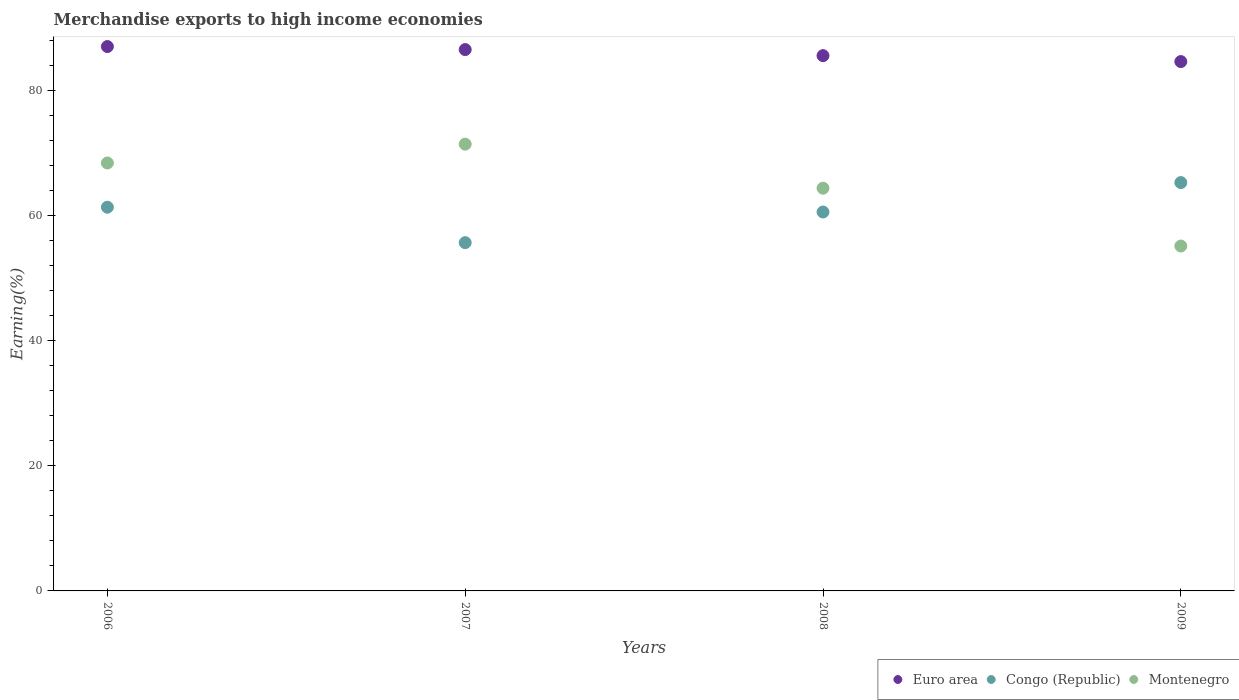How many different coloured dotlines are there?
Give a very brief answer. 3. Is the number of dotlines equal to the number of legend labels?
Give a very brief answer. Yes. What is the percentage of amount earned from merchandise exports in Montenegro in 2007?
Keep it short and to the point. 71.38. Across all years, what is the maximum percentage of amount earned from merchandise exports in Montenegro?
Offer a very short reply. 71.38. Across all years, what is the minimum percentage of amount earned from merchandise exports in Congo (Republic)?
Offer a very short reply. 55.64. In which year was the percentage of amount earned from merchandise exports in Euro area maximum?
Make the answer very short. 2006. In which year was the percentage of amount earned from merchandise exports in Euro area minimum?
Offer a terse response. 2009. What is the total percentage of amount earned from merchandise exports in Congo (Republic) in the graph?
Give a very brief answer. 242.73. What is the difference between the percentage of amount earned from merchandise exports in Montenegro in 2007 and that in 2008?
Ensure brevity in your answer.  7.04. What is the difference between the percentage of amount earned from merchandise exports in Euro area in 2007 and the percentage of amount earned from merchandise exports in Montenegro in 2009?
Give a very brief answer. 31.39. What is the average percentage of amount earned from merchandise exports in Congo (Republic) per year?
Provide a short and direct response. 60.68. In the year 2007, what is the difference between the percentage of amount earned from merchandise exports in Montenegro and percentage of amount earned from merchandise exports in Euro area?
Your answer should be very brief. -15.11. In how many years, is the percentage of amount earned from merchandise exports in Montenegro greater than 20 %?
Give a very brief answer. 4. What is the ratio of the percentage of amount earned from merchandise exports in Euro area in 2006 to that in 2009?
Provide a succinct answer. 1.03. Is the difference between the percentage of amount earned from merchandise exports in Montenegro in 2006 and 2008 greater than the difference between the percentage of amount earned from merchandise exports in Euro area in 2006 and 2008?
Your response must be concise. Yes. What is the difference between the highest and the second highest percentage of amount earned from merchandise exports in Euro area?
Ensure brevity in your answer.  0.48. What is the difference between the highest and the lowest percentage of amount earned from merchandise exports in Euro area?
Offer a terse response. 2.4. Is it the case that in every year, the sum of the percentage of amount earned from merchandise exports in Congo (Republic) and percentage of amount earned from merchandise exports in Euro area  is greater than the percentage of amount earned from merchandise exports in Montenegro?
Provide a succinct answer. Yes. Does the percentage of amount earned from merchandise exports in Euro area monotonically increase over the years?
Keep it short and to the point. No. Is the percentage of amount earned from merchandise exports in Congo (Republic) strictly less than the percentage of amount earned from merchandise exports in Euro area over the years?
Offer a very short reply. Yes. How many years are there in the graph?
Keep it short and to the point. 4. What is the difference between two consecutive major ticks on the Y-axis?
Offer a terse response. 20. Does the graph contain grids?
Provide a succinct answer. No. What is the title of the graph?
Your response must be concise. Merchandise exports to high income economies. Does "Nepal" appear as one of the legend labels in the graph?
Keep it short and to the point. No. What is the label or title of the X-axis?
Your answer should be very brief. Years. What is the label or title of the Y-axis?
Your response must be concise. Earning(%). What is the Earning(%) of Euro area in 2006?
Provide a short and direct response. 86.97. What is the Earning(%) of Congo (Republic) in 2006?
Your answer should be very brief. 61.3. What is the Earning(%) in Montenegro in 2006?
Provide a short and direct response. 68.37. What is the Earning(%) of Euro area in 2007?
Your response must be concise. 86.49. What is the Earning(%) in Congo (Republic) in 2007?
Your response must be concise. 55.64. What is the Earning(%) in Montenegro in 2007?
Offer a very short reply. 71.38. What is the Earning(%) in Euro area in 2008?
Your answer should be compact. 85.52. What is the Earning(%) of Congo (Republic) in 2008?
Your answer should be compact. 60.54. What is the Earning(%) of Montenegro in 2008?
Provide a succinct answer. 64.34. What is the Earning(%) in Euro area in 2009?
Your answer should be very brief. 84.57. What is the Earning(%) of Congo (Republic) in 2009?
Provide a succinct answer. 65.24. What is the Earning(%) of Montenegro in 2009?
Your answer should be very brief. 55.1. Across all years, what is the maximum Earning(%) in Euro area?
Give a very brief answer. 86.97. Across all years, what is the maximum Earning(%) in Congo (Republic)?
Provide a short and direct response. 65.24. Across all years, what is the maximum Earning(%) in Montenegro?
Provide a short and direct response. 71.38. Across all years, what is the minimum Earning(%) in Euro area?
Provide a short and direct response. 84.57. Across all years, what is the minimum Earning(%) of Congo (Republic)?
Offer a terse response. 55.64. Across all years, what is the minimum Earning(%) in Montenegro?
Offer a very short reply. 55.1. What is the total Earning(%) in Euro area in the graph?
Provide a succinct answer. 343.56. What is the total Earning(%) of Congo (Republic) in the graph?
Provide a short and direct response. 242.73. What is the total Earning(%) of Montenegro in the graph?
Keep it short and to the point. 259.2. What is the difference between the Earning(%) of Euro area in 2006 and that in 2007?
Offer a very short reply. 0.48. What is the difference between the Earning(%) of Congo (Republic) in 2006 and that in 2007?
Offer a very short reply. 5.66. What is the difference between the Earning(%) of Montenegro in 2006 and that in 2007?
Your answer should be compact. -3.01. What is the difference between the Earning(%) of Euro area in 2006 and that in 2008?
Offer a very short reply. 1.45. What is the difference between the Earning(%) of Congo (Republic) in 2006 and that in 2008?
Offer a terse response. 0.76. What is the difference between the Earning(%) in Montenegro in 2006 and that in 2008?
Your answer should be compact. 4.03. What is the difference between the Earning(%) in Euro area in 2006 and that in 2009?
Make the answer very short. 2.4. What is the difference between the Earning(%) in Congo (Republic) in 2006 and that in 2009?
Offer a very short reply. -3.94. What is the difference between the Earning(%) in Montenegro in 2006 and that in 2009?
Make the answer very short. 13.27. What is the difference between the Earning(%) in Euro area in 2007 and that in 2008?
Offer a terse response. 0.97. What is the difference between the Earning(%) in Congo (Republic) in 2007 and that in 2008?
Ensure brevity in your answer.  -4.9. What is the difference between the Earning(%) in Montenegro in 2007 and that in 2008?
Provide a succinct answer. 7.04. What is the difference between the Earning(%) of Euro area in 2007 and that in 2009?
Make the answer very short. 1.92. What is the difference between the Earning(%) in Congo (Republic) in 2007 and that in 2009?
Offer a very short reply. -9.6. What is the difference between the Earning(%) in Montenegro in 2007 and that in 2009?
Your answer should be very brief. 16.28. What is the difference between the Earning(%) of Euro area in 2008 and that in 2009?
Provide a short and direct response. 0.95. What is the difference between the Earning(%) of Congo (Republic) in 2008 and that in 2009?
Offer a terse response. -4.7. What is the difference between the Earning(%) in Montenegro in 2008 and that in 2009?
Offer a terse response. 9.24. What is the difference between the Earning(%) in Euro area in 2006 and the Earning(%) in Congo (Republic) in 2007?
Your response must be concise. 31.33. What is the difference between the Earning(%) of Euro area in 2006 and the Earning(%) of Montenegro in 2007?
Make the answer very short. 15.59. What is the difference between the Earning(%) of Congo (Republic) in 2006 and the Earning(%) of Montenegro in 2007?
Keep it short and to the point. -10.08. What is the difference between the Earning(%) of Euro area in 2006 and the Earning(%) of Congo (Republic) in 2008?
Offer a terse response. 26.43. What is the difference between the Earning(%) of Euro area in 2006 and the Earning(%) of Montenegro in 2008?
Your answer should be very brief. 22.63. What is the difference between the Earning(%) of Congo (Republic) in 2006 and the Earning(%) of Montenegro in 2008?
Give a very brief answer. -3.04. What is the difference between the Earning(%) of Euro area in 2006 and the Earning(%) of Congo (Republic) in 2009?
Your response must be concise. 21.73. What is the difference between the Earning(%) in Euro area in 2006 and the Earning(%) in Montenegro in 2009?
Your response must be concise. 31.87. What is the difference between the Earning(%) in Congo (Republic) in 2006 and the Earning(%) in Montenegro in 2009?
Your answer should be compact. 6.2. What is the difference between the Earning(%) in Euro area in 2007 and the Earning(%) in Congo (Republic) in 2008?
Your answer should be compact. 25.95. What is the difference between the Earning(%) in Euro area in 2007 and the Earning(%) in Montenegro in 2008?
Provide a succinct answer. 22.15. What is the difference between the Earning(%) of Congo (Republic) in 2007 and the Earning(%) of Montenegro in 2008?
Give a very brief answer. -8.7. What is the difference between the Earning(%) of Euro area in 2007 and the Earning(%) of Congo (Republic) in 2009?
Your response must be concise. 21.25. What is the difference between the Earning(%) in Euro area in 2007 and the Earning(%) in Montenegro in 2009?
Make the answer very short. 31.39. What is the difference between the Earning(%) in Congo (Republic) in 2007 and the Earning(%) in Montenegro in 2009?
Ensure brevity in your answer.  0.54. What is the difference between the Earning(%) of Euro area in 2008 and the Earning(%) of Congo (Republic) in 2009?
Offer a terse response. 20.28. What is the difference between the Earning(%) of Euro area in 2008 and the Earning(%) of Montenegro in 2009?
Provide a short and direct response. 30.42. What is the difference between the Earning(%) of Congo (Republic) in 2008 and the Earning(%) of Montenegro in 2009?
Offer a very short reply. 5.44. What is the average Earning(%) of Euro area per year?
Make the answer very short. 85.89. What is the average Earning(%) of Congo (Republic) per year?
Offer a terse response. 60.68. What is the average Earning(%) of Montenegro per year?
Your answer should be very brief. 64.8. In the year 2006, what is the difference between the Earning(%) of Euro area and Earning(%) of Congo (Republic)?
Give a very brief answer. 25.67. In the year 2006, what is the difference between the Earning(%) in Euro area and Earning(%) in Montenegro?
Your response must be concise. 18.6. In the year 2006, what is the difference between the Earning(%) of Congo (Republic) and Earning(%) of Montenegro?
Your response must be concise. -7.07. In the year 2007, what is the difference between the Earning(%) in Euro area and Earning(%) in Congo (Republic)?
Provide a short and direct response. 30.85. In the year 2007, what is the difference between the Earning(%) in Euro area and Earning(%) in Montenegro?
Provide a short and direct response. 15.11. In the year 2007, what is the difference between the Earning(%) of Congo (Republic) and Earning(%) of Montenegro?
Offer a terse response. -15.74. In the year 2008, what is the difference between the Earning(%) in Euro area and Earning(%) in Congo (Republic)?
Offer a very short reply. 24.98. In the year 2008, what is the difference between the Earning(%) of Euro area and Earning(%) of Montenegro?
Give a very brief answer. 21.18. In the year 2008, what is the difference between the Earning(%) of Congo (Republic) and Earning(%) of Montenegro?
Your response must be concise. -3.8. In the year 2009, what is the difference between the Earning(%) in Euro area and Earning(%) in Congo (Republic)?
Offer a very short reply. 19.33. In the year 2009, what is the difference between the Earning(%) in Euro area and Earning(%) in Montenegro?
Give a very brief answer. 29.47. In the year 2009, what is the difference between the Earning(%) of Congo (Republic) and Earning(%) of Montenegro?
Ensure brevity in your answer.  10.14. What is the ratio of the Earning(%) in Euro area in 2006 to that in 2007?
Keep it short and to the point. 1.01. What is the ratio of the Earning(%) of Congo (Republic) in 2006 to that in 2007?
Keep it short and to the point. 1.1. What is the ratio of the Earning(%) of Montenegro in 2006 to that in 2007?
Give a very brief answer. 0.96. What is the ratio of the Earning(%) in Euro area in 2006 to that in 2008?
Keep it short and to the point. 1.02. What is the ratio of the Earning(%) of Congo (Republic) in 2006 to that in 2008?
Offer a terse response. 1.01. What is the ratio of the Earning(%) of Montenegro in 2006 to that in 2008?
Your answer should be very brief. 1.06. What is the ratio of the Earning(%) in Euro area in 2006 to that in 2009?
Make the answer very short. 1.03. What is the ratio of the Earning(%) in Congo (Republic) in 2006 to that in 2009?
Your response must be concise. 0.94. What is the ratio of the Earning(%) in Montenegro in 2006 to that in 2009?
Provide a short and direct response. 1.24. What is the ratio of the Earning(%) of Euro area in 2007 to that in 2008?
Provide a succinct answer. 1.01. What is the ratio of the Earning(%) of Congo (Republic) in 2007 to that in 2008?
Your answer should be compact. 0.92. What is the ratio of the Earning(%) of Montenegro in 2007 to that in 2008?
Keep it short and to the point. 1.11. What is the ratio of the Earning(%) in Euro area in 2007 to that in 2009?
Your answer should be compact. 1.02. What is the ratio of the Earning(%) in Congo (Republic) in 2007 to that in 2009?
Keep it short and to the point. 0.85. What is the ratio of the Earning(%) in Montenegro in 2007 to that in 2009?
Your response must be concise. 1.3. What is the ratio of the Earning(%) in Euro area in 2008 to that in 2009?
Your answer should be very brief. 1.01. What is the ratio of the Earning(%) of Congo (Republic) in 2008 to that in 2009?
Your answer should be compact. 0.93. What is the ratio of the Earning(%) of Montenegro in 2008 to that in 2009?
Provide a succinct answer. 1.17. What is the difference between the highest and the second highest Earning(%) of Euro area?
Provide a short and direct response. 0.48. What is the difference between the highest and the second highest Earning(%) of Congo (Republic)?
Your response must be concise. 3.94. What is the difference between the highest and the second highest Earning(%) in Montenegro?
Make the answer very short. 3.01. What is the difference between the highest and the lowest Earning(%) in Euro area?
Ensure brevity in your answer.  2.4. What is the difference between the highest and the lowest Earning(%) in Congo (Republic)?
Give a very brief answer. 9.6. What is the difference between the highest and the lowest Earning(%) in Montenegro?
Make the answer very short. 16.28. 